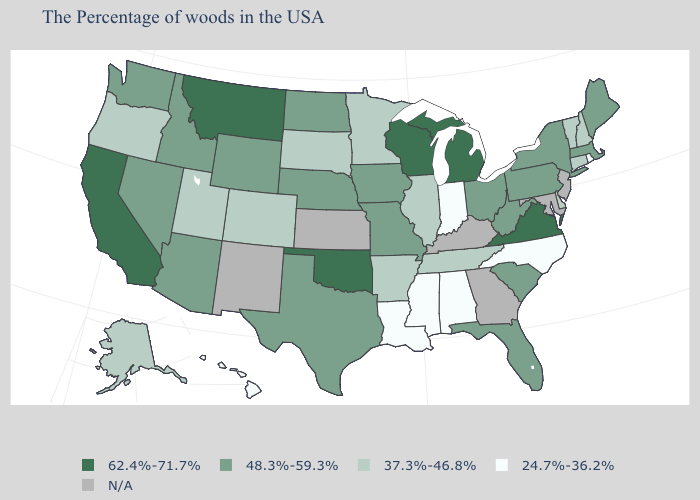Which states have the lowest value in the USA?
Short answer required. Rhode Island, North Carolina, Indiana, Alabama, Mississippi, Louisiana, Hawaii. What is the value of Georgia?
Short answer required. N/A. Does Virginia have the highest value in the South?
Write a very short answer. Yes. What is the lowest value in the MidWest?
Answer briefly. 24.7%-36.2%. Name the states that have a value in the range 37.3%-46.8%?
Give a very brief answer. New Hampshire, Vermont, Connecticut, Delaware, Tennessee, Illinois, Arkansas, Minnesota, South Dakota, Colorado, Utah, Oregon, Alaska. What is the value of Connecticut?
Short answer required. 37.3%-46.8%. Name the states that have a value in the range 62.4%-71.7%?
Quick response, please. Virginia, Michigan, Wisconsin, Oklahoma, Montana, California. What is the value of Wyoming?
Be succinct. 48.3%-59.3%. How many symbols are there in the legend?
Give a very brief answer. 5. Does the map have missing data?
Concise answer only. Yes. Does Alabama have the highest value in the South?
Answer briefly. No. Does Alaska have the lowest value in the West?
Short answer required. No. What is the highest value in the Northeast ?
Be succinct. 48.3%-59.3%. What is the value of Hawaii?
Keep it brief. 24.7%-36.2%. 